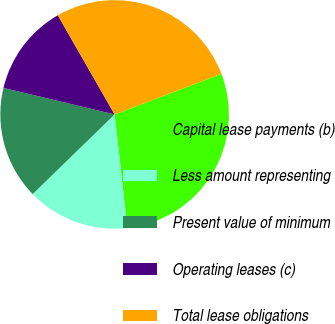Convert chart to OTSL. <chart><loc_0><loc_0><loc_500><loc_500><pie_chart><fcel>Capital lease payments (b)<fcel>Less amount representing<fcel>Present value of minimum<fcel>Operating leases (c)<fcel>Total lease obligations<nl><fcel>29.01%<fcel>14.5%<fcel>16.0%<fcel>12.99%<fcel>27.5%<nl></chart> 